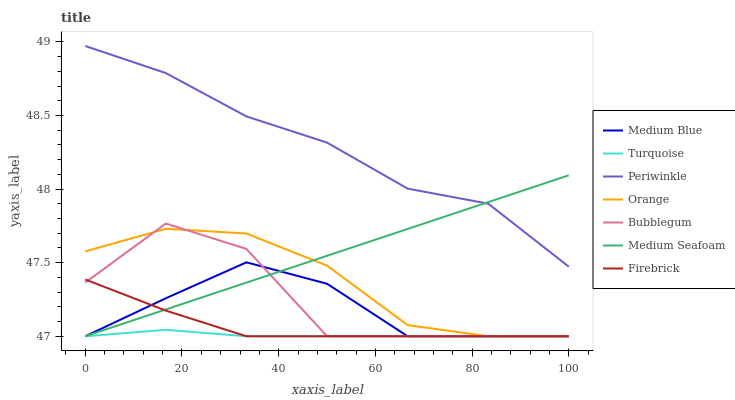Does Turquoise have the minimum area under the curve?
Answer yes or no. Yes. Does Periwinkle have the maximum area under the curve?
Answer yes or no. Yes. Does Firebrick have the minimum area under the curve?
Answer yes or no. No. Does Firebrick have the maximum area under the curve?
Answer yes or no. No. Is Medium Seafoam the smoothest?
Answer yes or no. Yes. Is Bubblegum the roughest?
Answer yes or no. Yes. Is Firebrick the smoothest?
Answer yes or no. No. Is Firebrick the roughest?
Answer yes or no. No. Does Periwinkle have the lowest value?
Answer yes or no. No. Does Firebrick have the highest value?
Answer yes or no. No. Is Medium Blue less than Periwinkle?
Answer yes or no. Yes. Is Periwinkle greater than Bubblegum?
Answer yes or no. Yes. Does Medium Blue intersect Periwinkle?
Answer yes or no. No. 